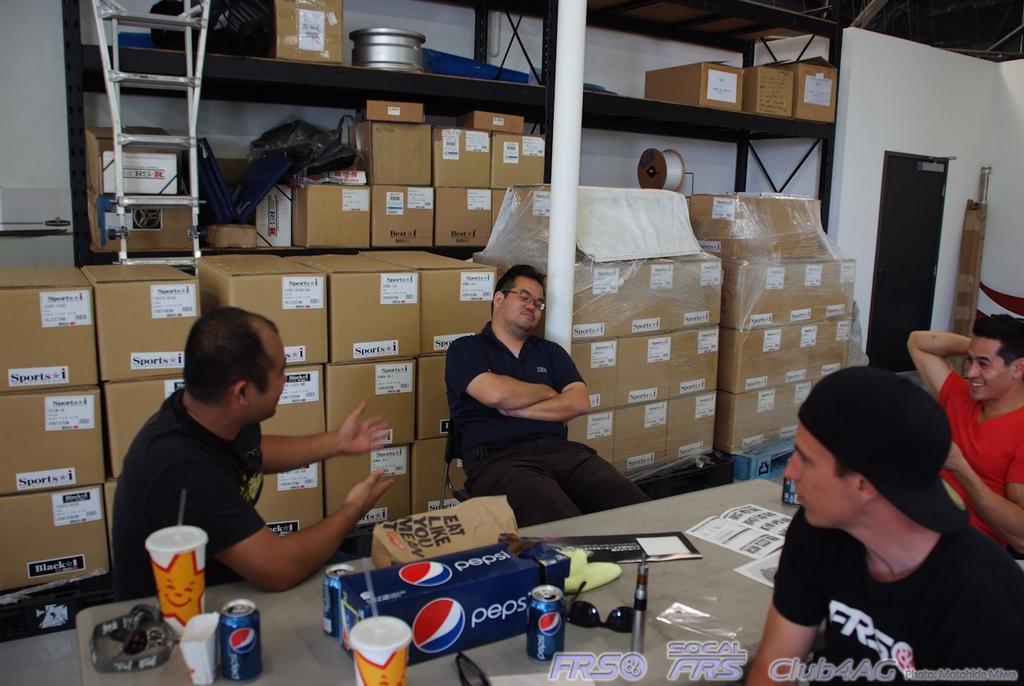Please provide a concise description of this image. As we can see in the image, there are four people sitting around table. On table there is a tin, glass, goggles, box and a book. Behind these two people there are few boxes. On the right side there is white color wall. 